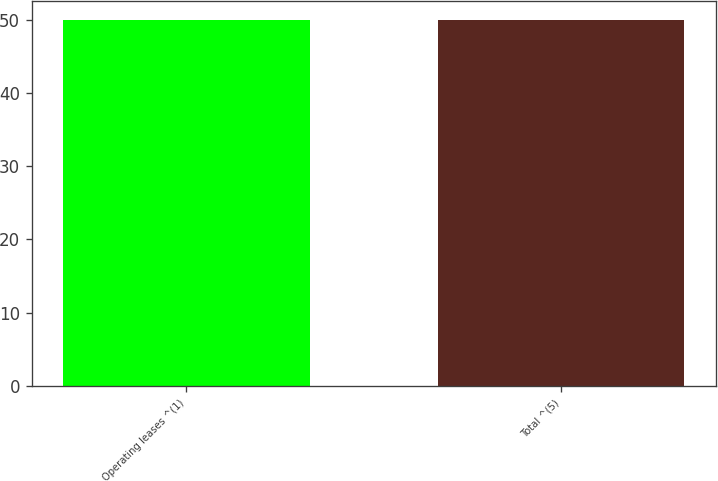<chart> <loc_0><loc_0><loc_500><loc_500><bar_chart><fcel>Operating leases ^(1)<fcel>Total ^(5)<nl><fcel>49.9<fcel>50<nl></chart> 